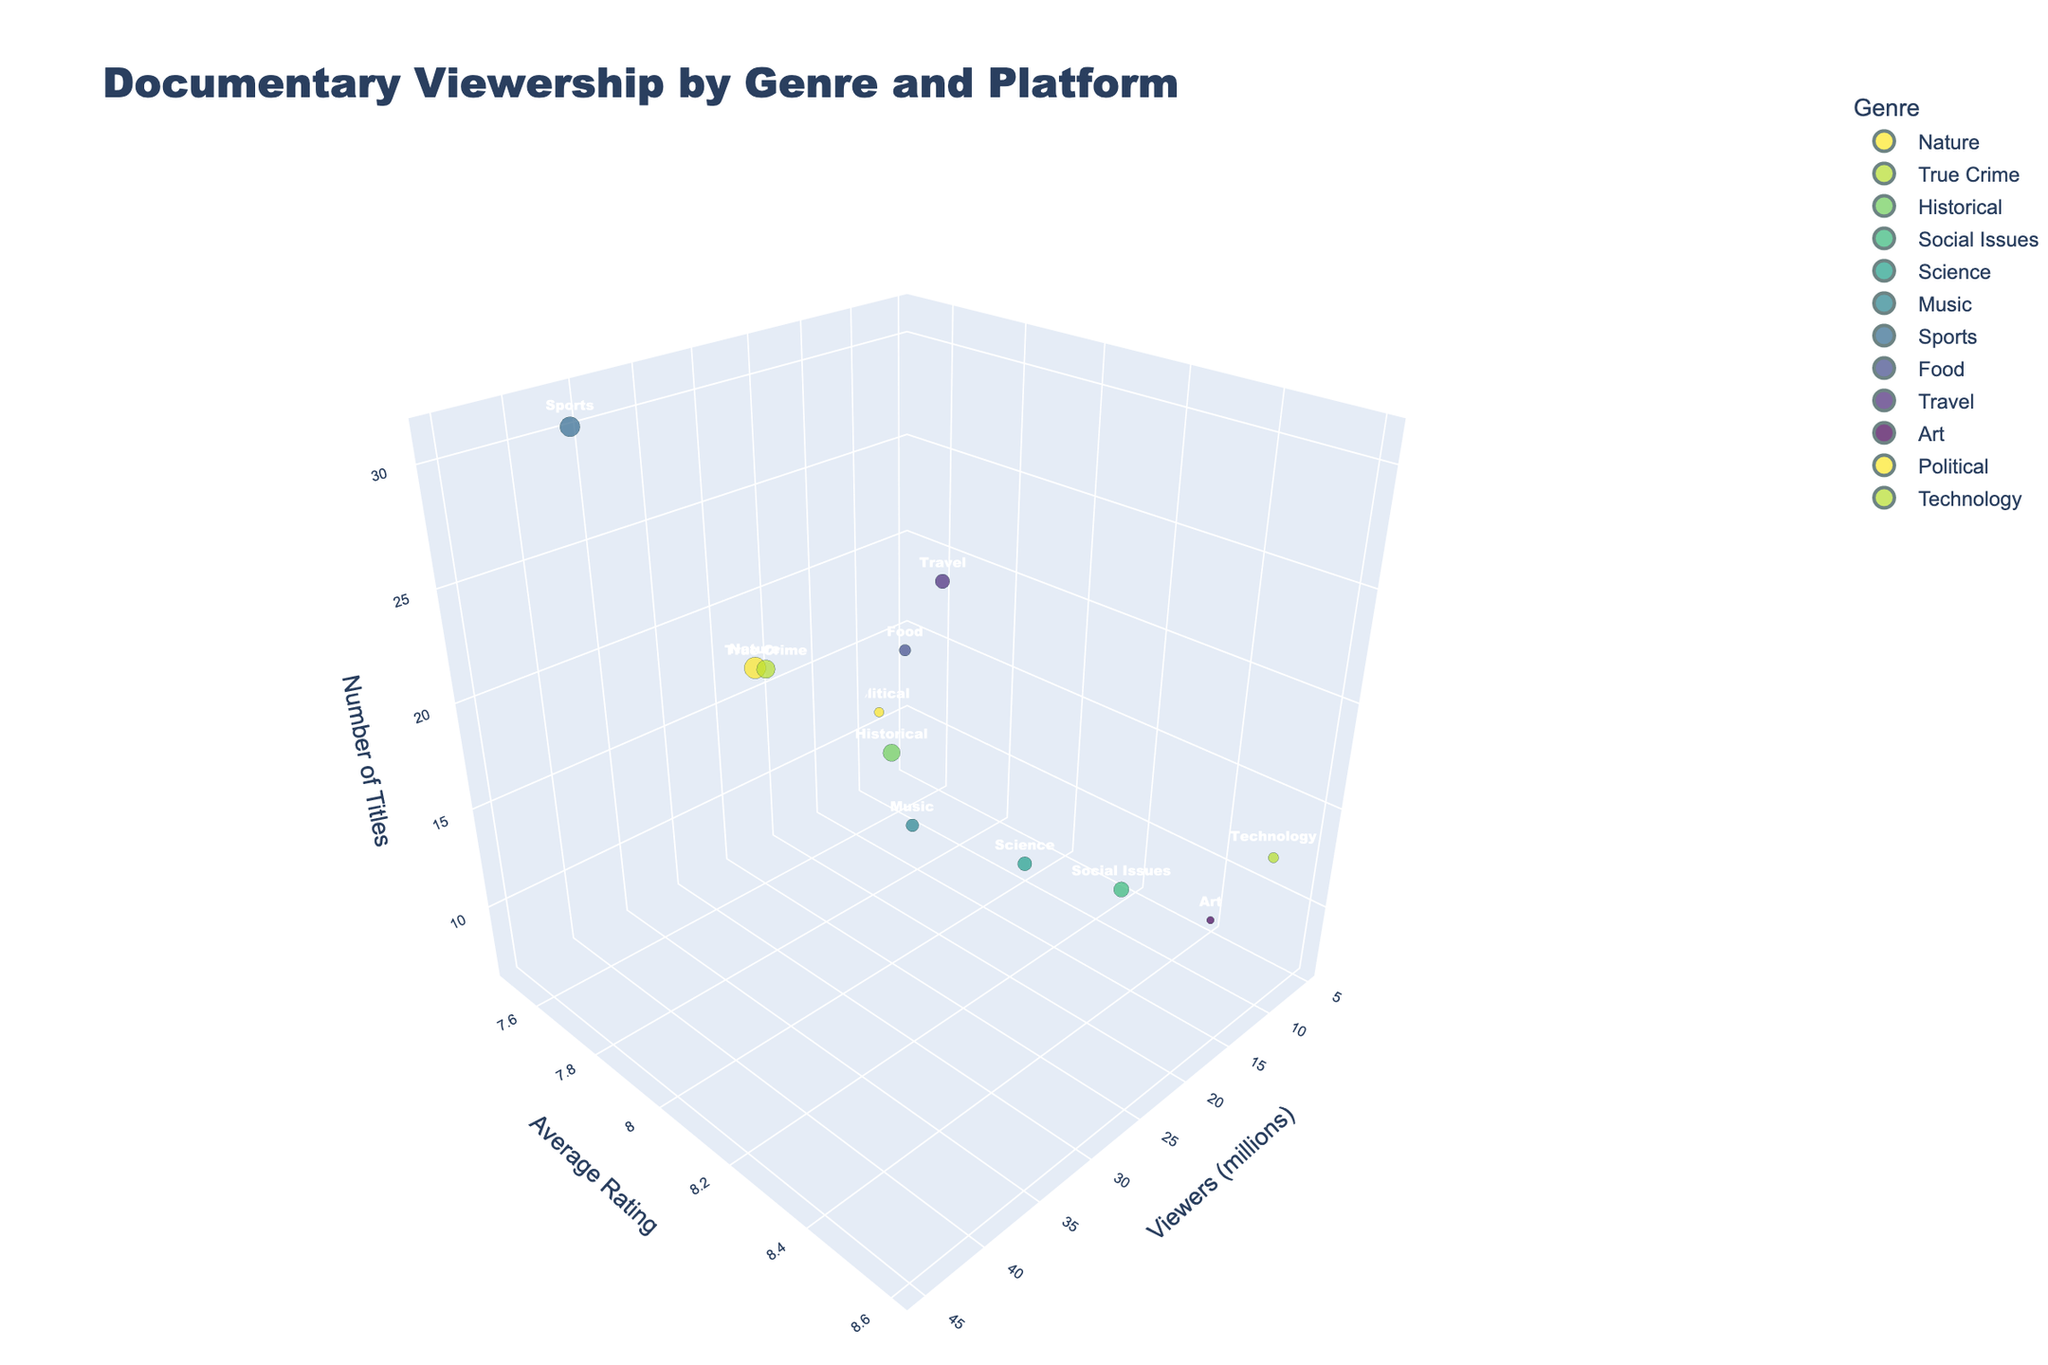How many documentary films are listed for Netflix? Look for the genre labeled 'Nature' as Netflix's platform and note the value for 'Number of Titles'.
Answer: 28 Which genre has the highest average rating, and what platform is it on? Identify the highest value on the 'Average Rating' axis, then check the corresponding genre and platform.
Answer: Technology, Curiosity Stream How does the number of titles for Sports documentaries on YouTube compare to the number for Nature documentaries on Netflix? Locate the 'Sports' genre on YouTube and the 'Nature' genre on Netflix, then compare their 'Number of Titles'.
Answer: 31 vs. 28 What's the total number of viewers for the genres listed on Disney+ and Apple TV+ combined? Note the 'Viewers (millions)' for 'Science' on Disney+ and 'Music' on Apple TV+, then sum them.
Answer: 34.5 million Which genre has the smallest audience, and how many viewers does it have? Find the smallest value on the 'Viewers (millions)' axis and identify the corresponding genre.
Answer: Art, 5.3 million What is the difference in the average rating between Political documentaries on CNN+ and Historical documentaries on Amazon Prime? Locate 'Political' on CNN+ and 'Historical' on Amazon Prime, then subtract their 'Average Rating' values.
Answer: 0.6 Between 'True Crime' on Hulu and 'Travel' on National Geographic, which has higher average ratings and by how much? Compare the 'Average Rating' for both 'True Crime' on Hulu and 'Travel' on National Geographic, then calculate the difference.
Answer: Travel, 0.1 higher How many genres have an audience larger than 20 million viewers? Count the genres with 'Viewers (millions)' above 20 million.
Answer: 5 What's the bubble size for documentaries on Discovery+, and what does the size represent in this plot? Check the size of the bubble for 'Food' on Discovery+, indicating its viewers.
Answer: 12.8 million viewers 